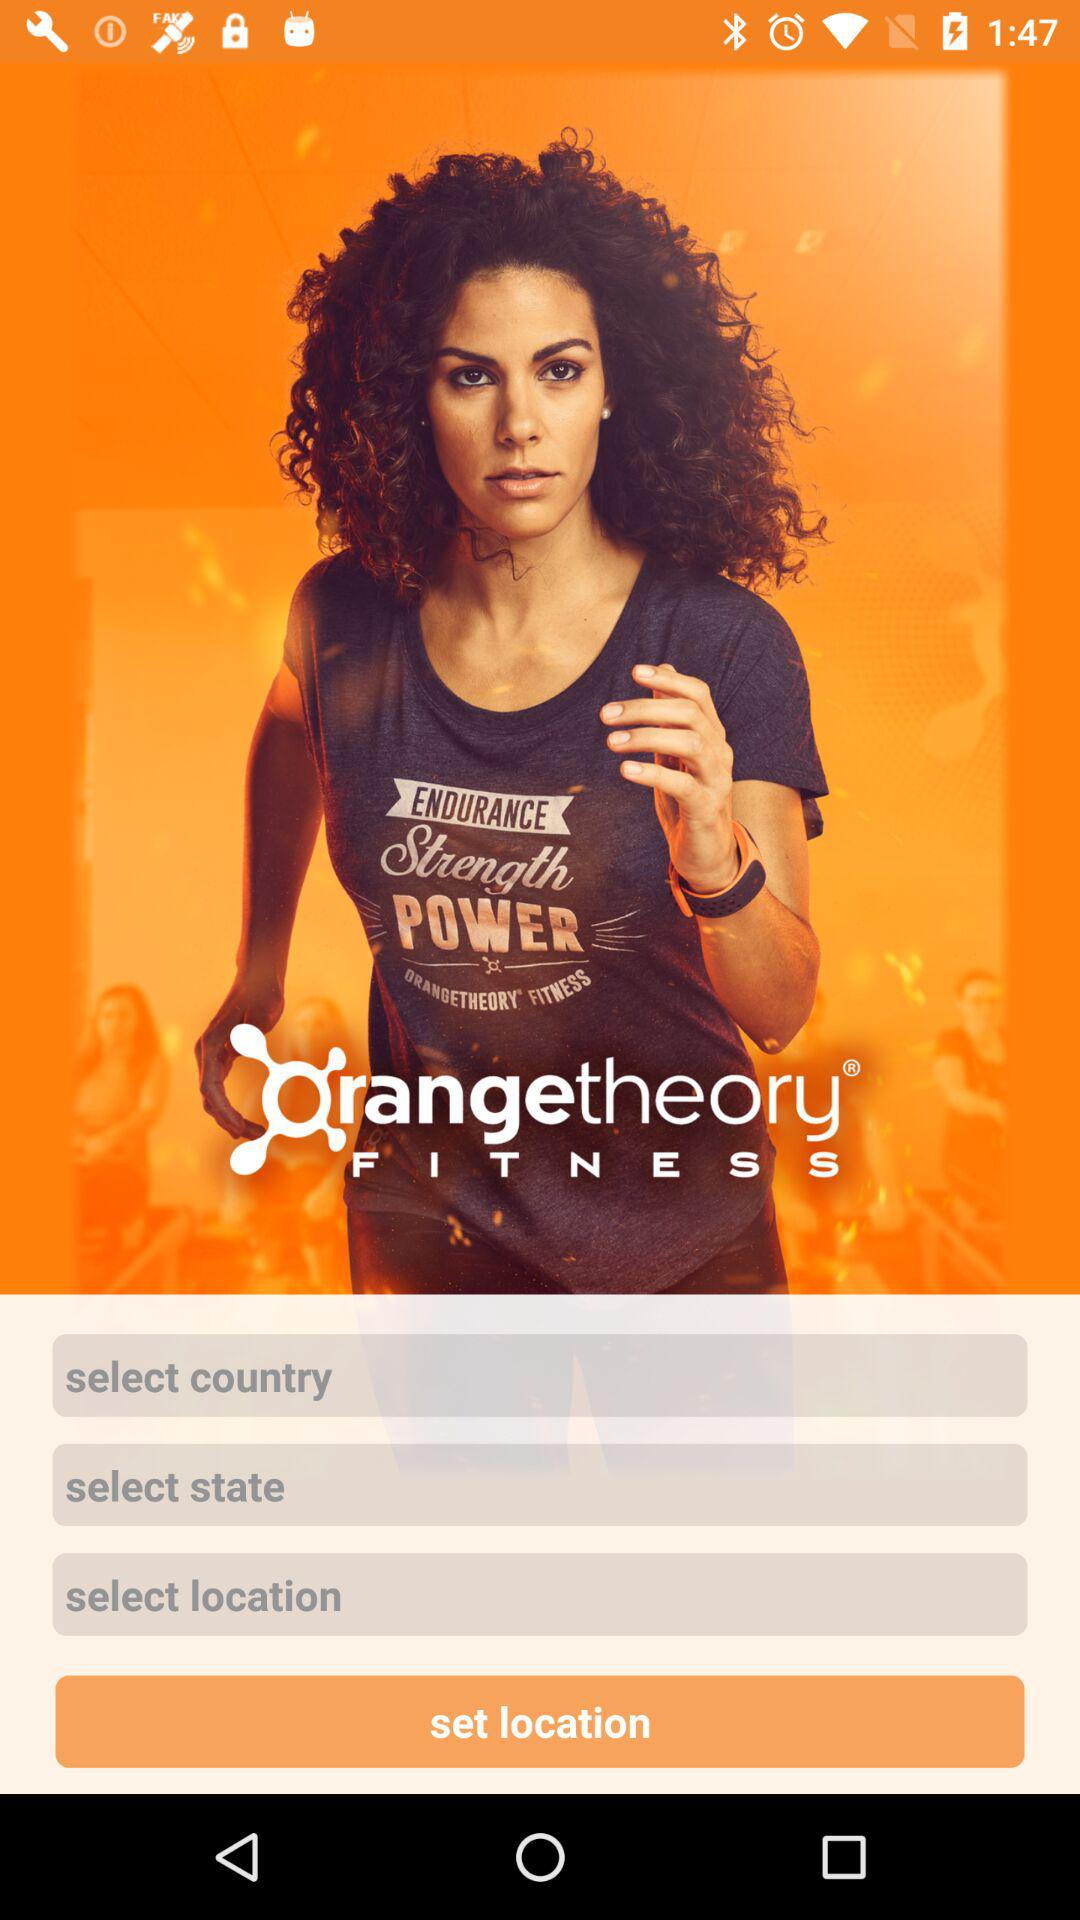What is the application name? The application name is "Orangetheory FITNESS". 